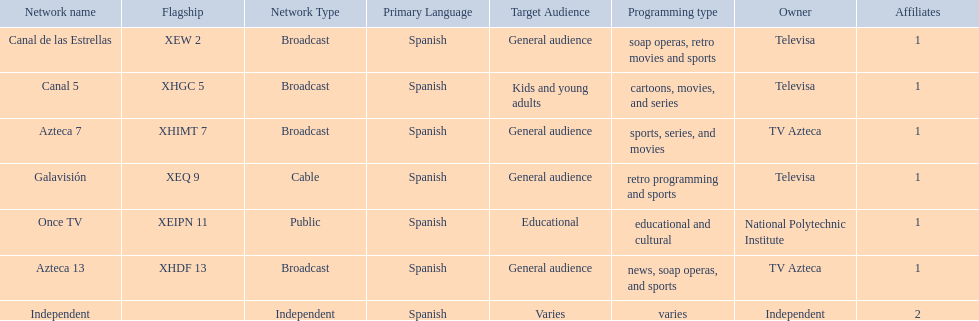What is the number of networks that are owned by televisa? 3. 